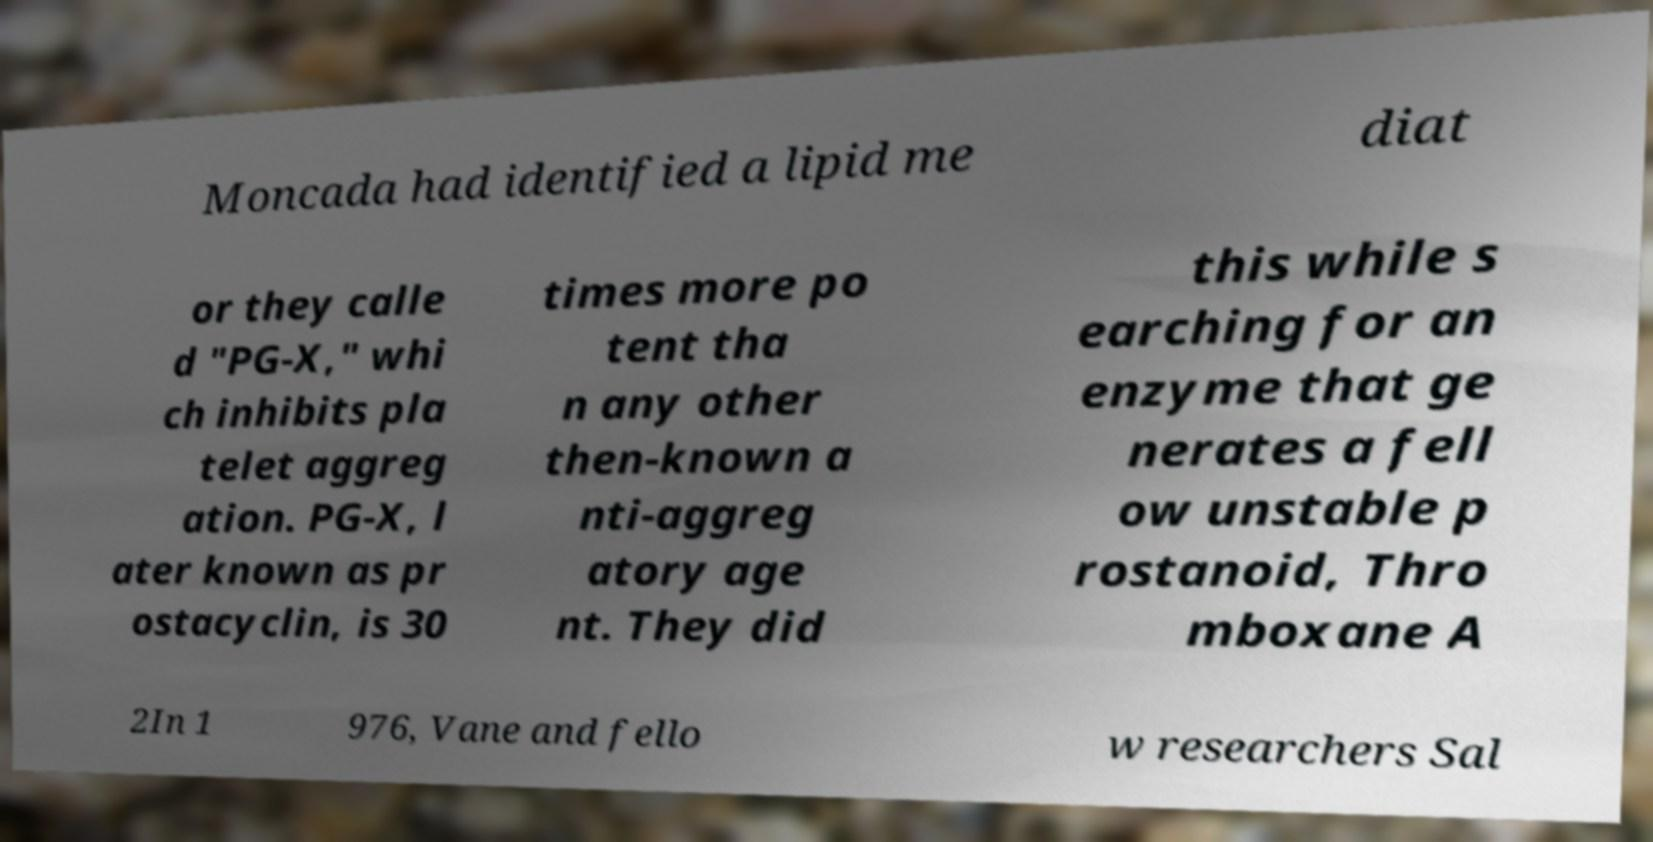I need the written content from this picture converted into text. Can you do that? Moncada had identified a lipid me diat or they calle d "PG-X," whi ch inhibits pla telet aggreg ation. PG-X, l ater known as pr ostacyclin, is 30 times more po tent tha n any other then-known a nti-aggreg atory age nt. They did this while s earching for an enzyme that ge nerates a fell ow unstable p rostanoid, Thro mboxane A 2In 1 976, Vane and fello w researchers Sal 